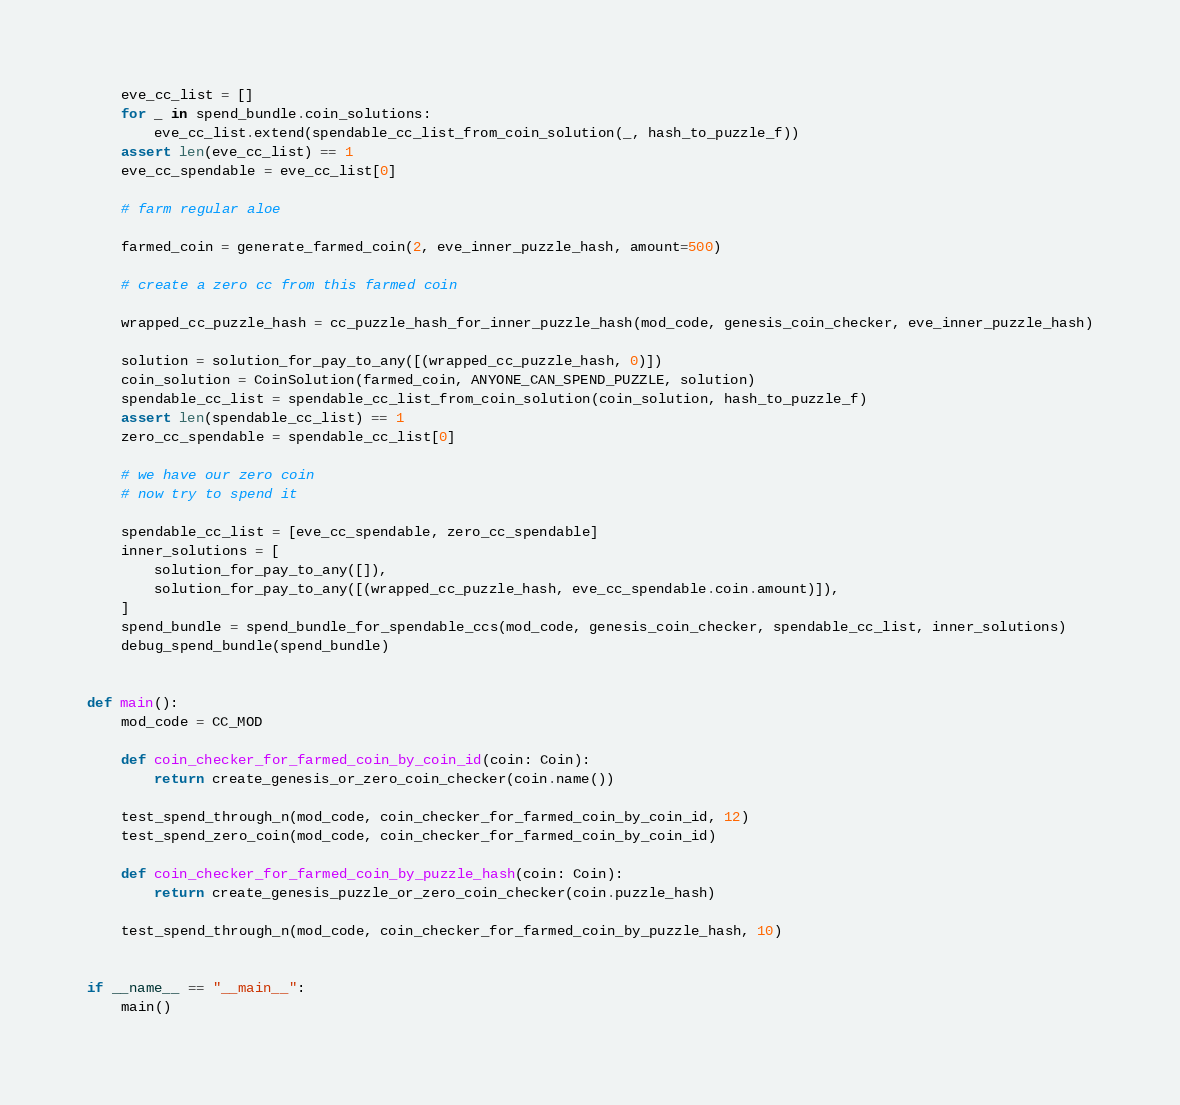Convert code to text. <code><loc_0><loc_0><loc_500><loc_500><_Python_>
    eve_cc_list = []
    for _ in spend_bundle.coin_solutions:
        eve_cc_list.extend(spendable_cc_list_from_coin_solution(_, hash_to_puzzle_f))
    assert len(eve_cc_list) == 1
    eve_cc_spendable = eve_cc_list[0]

    # farm regular aloe

    farmed_coin = generate_farmed_coin(2, eve_inner_puzzle_hash, amount=500)

    # create a zero cc from this farmed coin

    wrapped_cc_puzzle_hash = cc_puzzle_hash_for_inner_puzzle_hash(mod_code, genesis_coin_checker, eve_inner_puzzle_hash)

    solution = solution_for_pay_to_any([(wrapped_cc_puzzle_hash, 0)])
    coin_solution = CoinSolution(farmed_coin, ANYONE_CAN_SPEND_PUZZLE, solution)
    spendable_cc_list = spendable_cc_list_from_coin_solution(coin_solution, hash_to_puzzle_f)
    assert len(spendable_cc_list) == 1
    zero_cc_spendable = spendable_cc_list[0]

    # we have our zero coin
    # now try to spend it

    spendable_cc_list = [eve_cc_spendable, zero_cc_spendable]
    inner_solutions = [
        solution_for_pay_to_any([]),
        solution_for_pay_to_any([(wrapped_cc_puzzle_hash, eve_cc_spendable.coin.amount)]),
    ]
    spend_bundle = spend_bundle_for_spendable_ccs(mod_code, genesis_coin_checker, spendable_cc_list, inner_solutions)
    debug_spend_bundle(spend_bundle)


def main():
    mod_code = CC_MOD

    def coin_checker_for_farmed_coin_by_coin_id(coin: Coin):
        return create_genesis_or_zero_coin_checker(coin.name())

    test_spend_through_n(mod_code, coin_checker_for_farmed_coin_by_coin_id, 12)
    test_spend_zero_coin(mod_code, coin_checker_for_farmed_coin_by_coin_id)

    def coin_checker_for_farmed_coin_by_puzzle_hash(coin: Coin):
        return create_genesis_puzzle_or_zero_coin_checker(coin.puzzle_hash)

    test_spend_through_n(mod_code, coin_checker_for_farmed_coin_by_puzzle_hash, 10)


if __name__ == "__main__":
    main()
</code> 